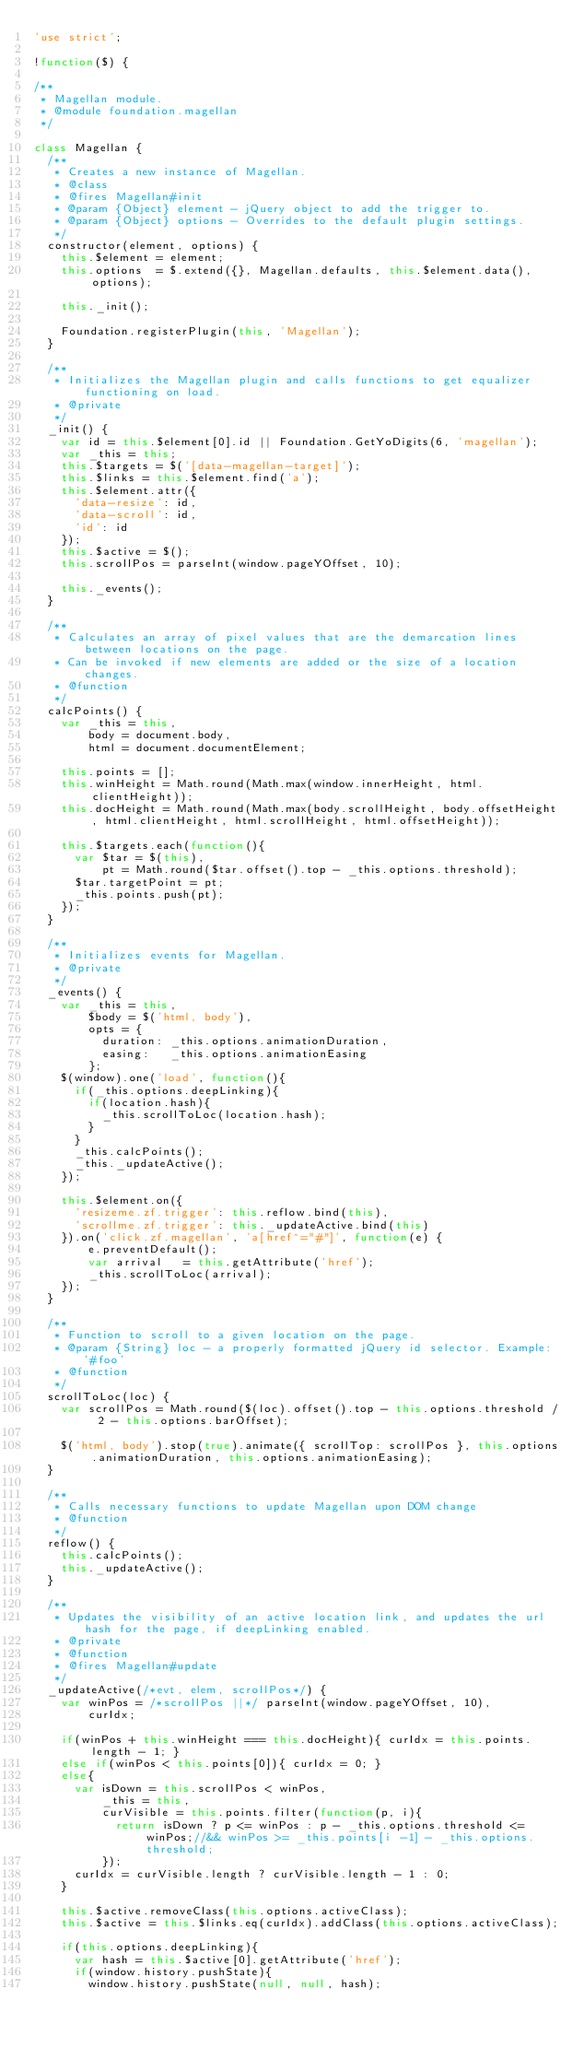Convert code to text. <code><loc_0><loc_0><loc_500><loc_500><_JavaScript_>'use strict';

!function($) {

/**
 * Magellan module.
 * @module foundation.magellan
 */

class Magellan {
  /**
   * Creates a new instance of Magellan.
   * @class
   * @fires Magellan#init
   * @param {Object} element - jQuery object to add the trigger to.
   * @param {Object} options - Overrides to the default plugin settings.
   */
  constructor(element, options) {
    this.$element = element;
    this.options  = $.extend({}, Magellan.defaults, this.$element.data(), options);

    this._init();

    Foundation.registerPlugin(this, 'Magellan');
  }

  /**
   * Initializes the Magellan plugin and calls functions to get equalizer functioning on load.
   * @private
   */
  _init() {
    var id = this.$element[0].id || Foundation.GetYoDigits(6, 'magellan');
    var _this = this;
    this.$targets = $('[data-magellan-target]');
    this.$links = this.$element.find('a');
    this.$element.attr({
      'data-resize': id,
      'data-scroll': id,
      'id': id
    });
    this.$active = $();
    this.scrollPos = parseInt(window.pageYOffset, 10);

    this._events();
  }

  /**
   * Calculates an array of pixel values that are the demarcation lines between locations on the page.
   * Can be invoked if new elements are added or the size of a location changes.
   * @function
   */
  calcPoints() {
    var _this = this,
        body = document.body,
        html = document.documentElement;

    this.points = [];
    this.winHeight = Math.round(Math.max(window.innerHeight, html.clientHeight));
    this.docHeight = Math.round(Math.max(body.scrollHeight, body.offsetHeight, html.clientHeight, html.scrollHeight, html.offsetHeight));

    this.$targets.each(function(){
      var $tar = $(this),
          pt = Math.round($tar.offset().top - _this.options.threshold);
      $tar.targetPoint = pt;
      _this.points.push(pt);
    });
  }

  /**
   * Initializes events for Magellan.
   * @private
   */
  _events() {
    var _this = this,
        $body = $('html, body'),
        opts = {
          duration: _this.options.animationDuration,
          easing:   _this.options.animationEasing
        };
    $(window).one('load', function(){
      if(_this.options.deepLinking){
        if(location.hash){
          _this.scrollToLoc(location.hash);
        }
      }
      _this.calcPoints();
      _this._updateActive();
    });

    this.$element.on({
      'resizeme.zf.trigger': this.reflow.bind(this),
      'scrollme.zf.trigger': this._updateActive.bind(this)
    }).on('click.zf.magellan', 'a[href^="#"]', function(e) {
        e.preventDefault();
        var arrival   = this.getAttribute('href');
        _this.scrollToLoc(arrival);
    });
  }

  /**
   * Function to scroll to a given location on the page.
   * @param {String} loc - a properly formatted jQuery id selector. Example: '#foo'
   * @function
   */
  scrollToLoc(loc) {
    var scrollPos = Math.round($(loc).offset().top - this.options.threshold / 2 - this.options.barOffset);

    $('html, body').stop(true).animate({ scrollTop: scrollPos }, this.options.animationDuration, this.options.animationEasing);
  }

  /**
   * Calls necessary functions to update Magellan upon DOM change
   * @function
   */
  reflow() {
    this.calcPoints();
    this._updateActive();
  }

  /**
   * Updates the visibility of an active location link, and updates the url hash for the page, if deepLinking enabled.
   * @private
   * @function
   * @fires Magellan#update
   */
  _updateActive(/*evt, elem, scrollPos*/) {
    var winPos = /*scrollPos ||*/ parseInt(window.pageYOffset, 10),
        curIdx;

    if(winPos + this.winHeight === this.docHeight){ curIdx = this.points.length - 1; }
    else if(winPos < this.points[0]){ curIdx = 0; }
    else{
      var isDown = this.scrollPos < winPos,
          _this = this,
          curVisible = this.points.filter(function(p, i){
            return isDown ? p <= winPos : p - _this.options.threshold <= winPos;//&& winPos >= _this.points[i -1] - _this.options.threshold;
          });
      curIdx = curVisible.length ? curVisible.length - 1 : 0;
    }

    this.$active.removeClass(this.options.activeClass);
    this.$active = this.$links.eq(curIdx).addClass(this.options.activeClass);

    if(this.options.deepLinking){
      var hash = this.$active[0].getAttribute('href');
      if(window.history.pushState){
        window.history.pushState(null, null, hash);</code> 